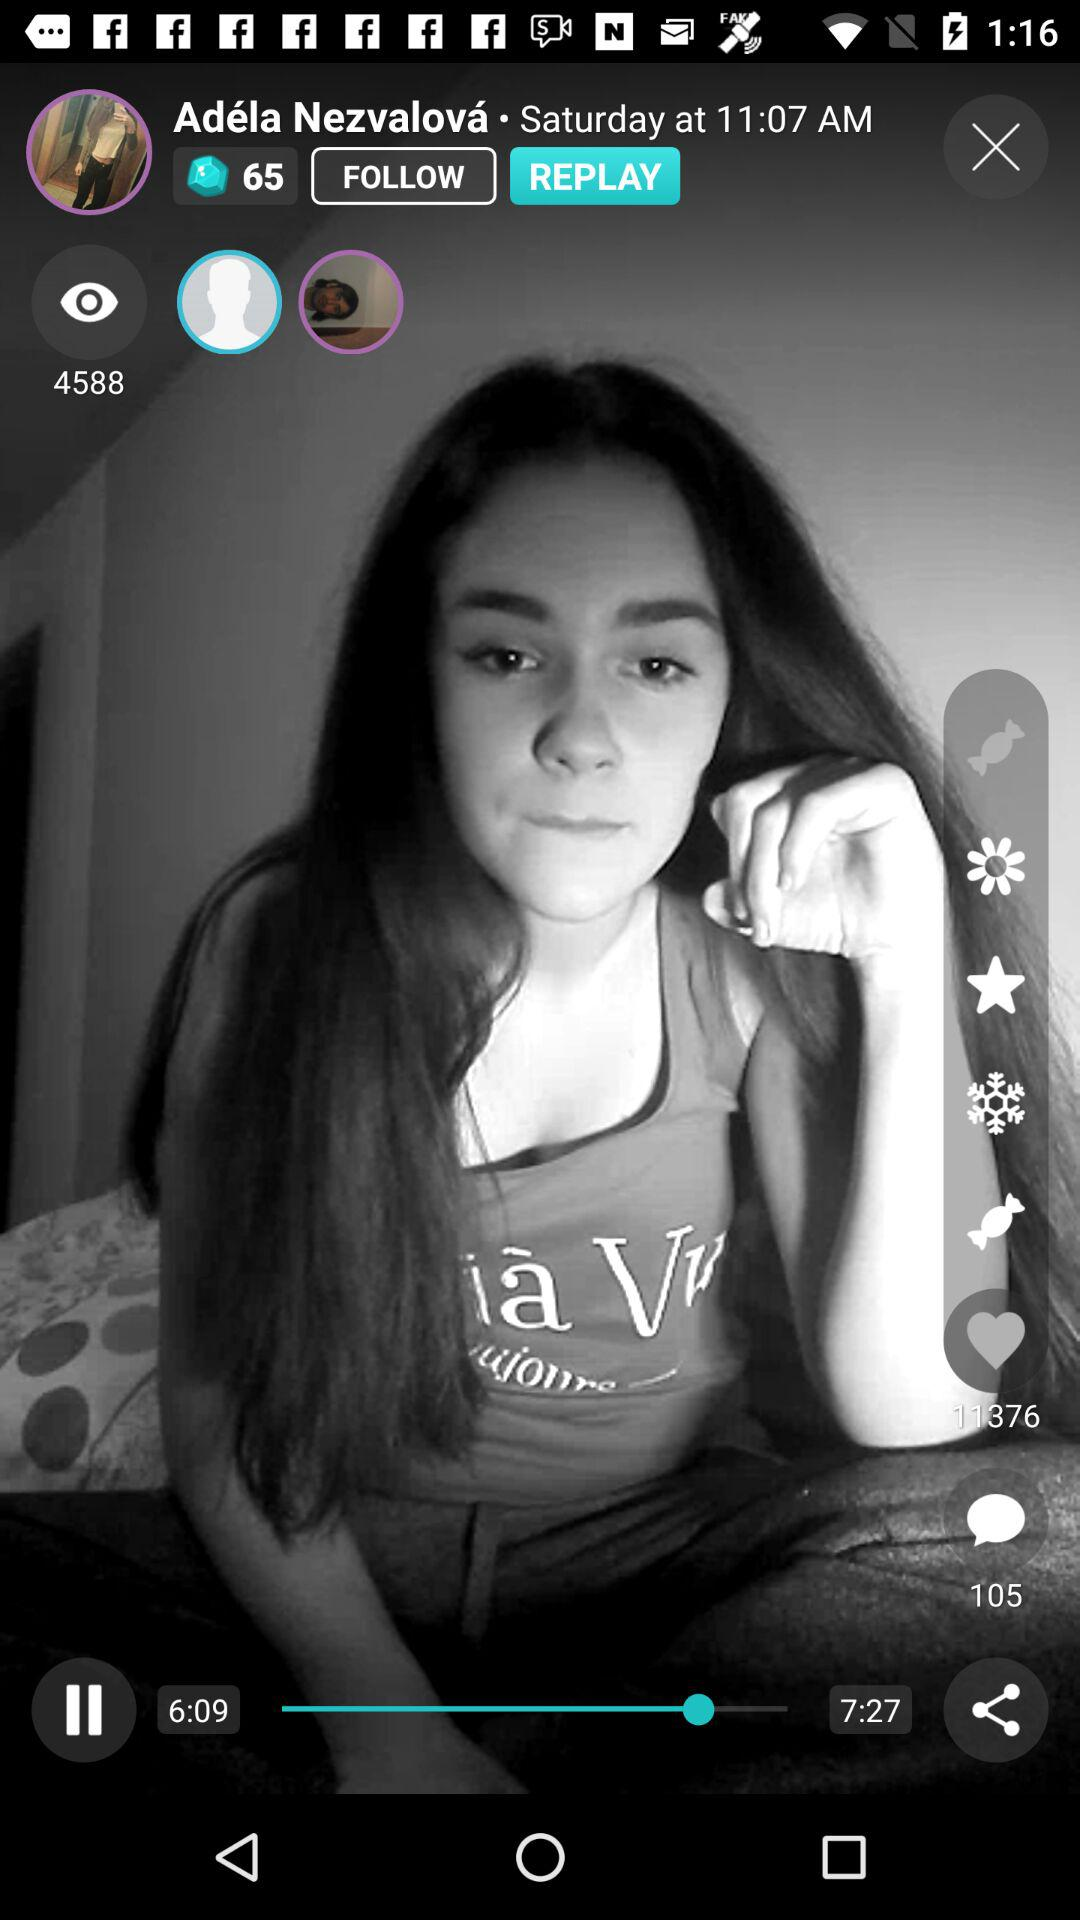What is the mentioned day? The mentioned day is Saturday. 